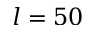Convert formula to latex. <formula><loc_0><loc_0><loc_500><loc_500>l = 5 0</formula> 